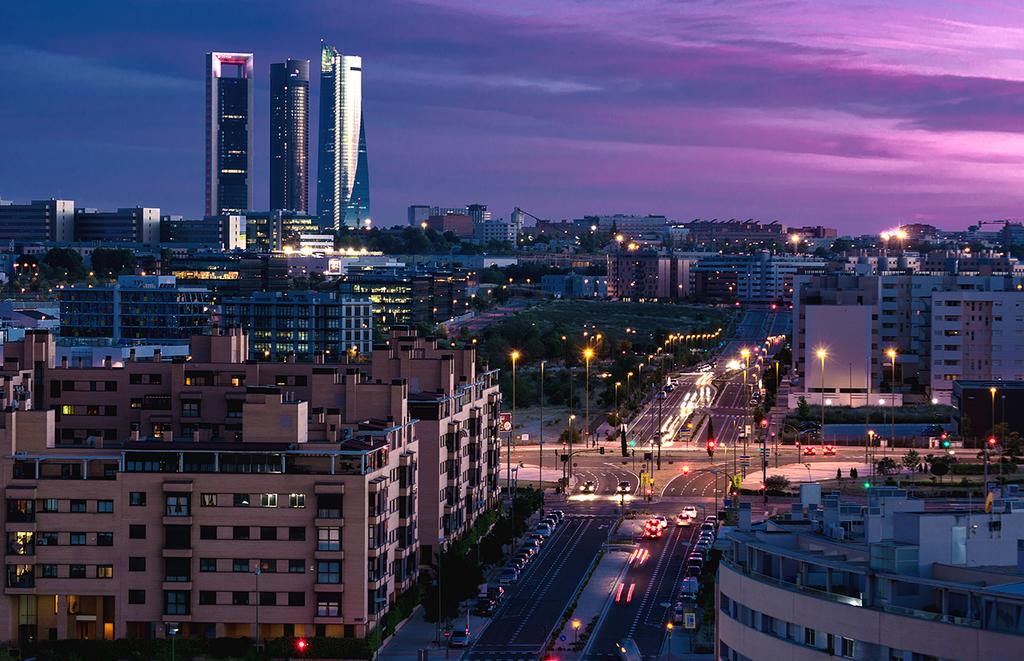What is the main feature in the center of the image? There is a road in the center of the image. What is happening on the road? Cars are present on the road. What else can be seen in the image besides the road and cars? There are poles and buildings visible in the image. What is visible at the top of the image? The sky is visible at the top of the image. Can you see your mom riding a horse in the image? There is no mom or horse present in the image. 